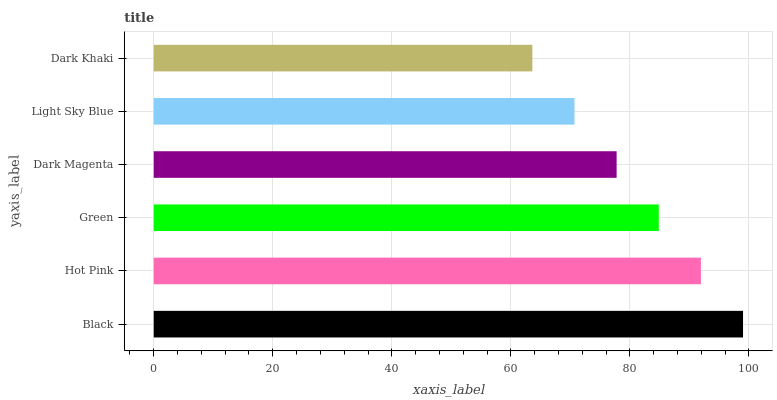Is Dark Khaki the minimum?
Answer yes or no. Yes. Is Black the maximum?
Answer yes or no. Yes. Is Hot Pink the minimum?
Answer yes or no. No. Is Hot Pink the maximum?
Answer yes or no. No. Is Black greater than Hot Pink?
Answer yes or no. Yes. Is Hot Pink less than Black?
Answer yes or no. Yes. Is Hot Pink greater than Black?
Answer yes or no. No. Is Black less than Hot Pink?
Answer yes or no. No. Is Green the high median?
Answer yes or no. Yes. Is Dark Magenta the low median?
Answer yes or no. Yes. Is Hot Pink the high median?
Answer yes or no. No. Is Light Sky Blue the low median?
Answer yes or no. No. 